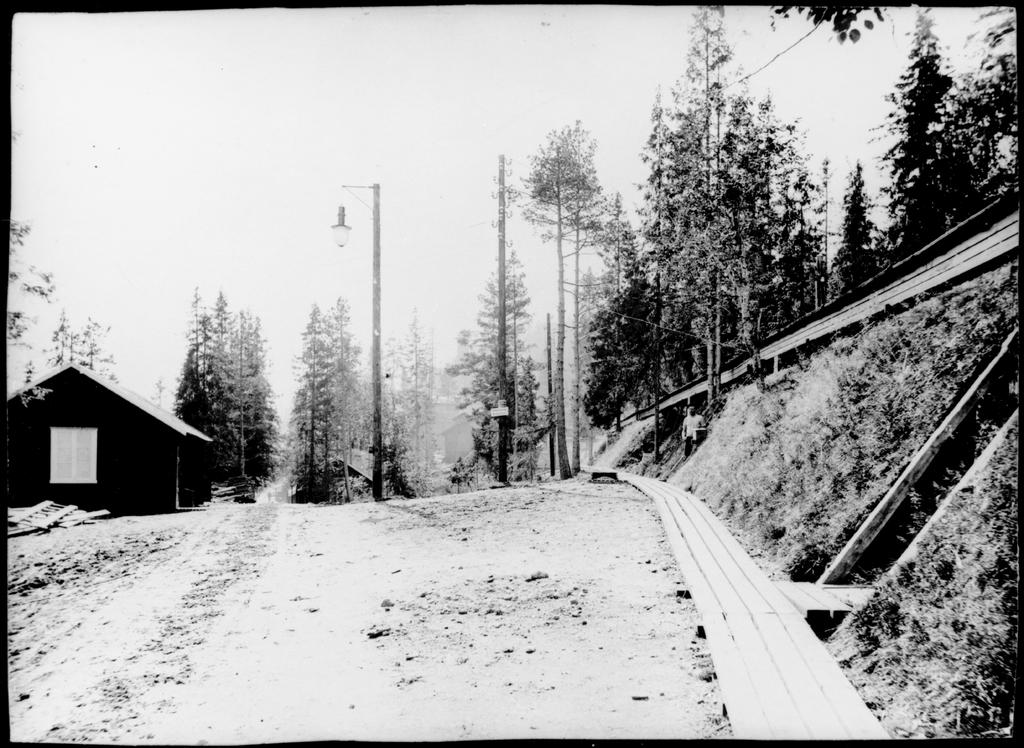What type of vegetation is in the middle of the image? There are trees in the middle of the image. What type of structure is visible in the image? There is a house in the image. Who is present in the image? There is a man in the image. What type of terrain is visible in the image? There is grassland in the image. What type of lighting is present in the image? There is a streetlight in the image. What type of objects are present in the image? There are poles in the image. What part of the natural environment is visible in the image? The sky is visible in the image. What substance is being discussed by the man in the image? There is no indication in the image that the man is discussing any substance. How does the comparison between the trees and the poles in the image affect the overall composition? There is no comparison between the trees and the poles in the image, as they are separate objects. 